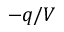Convert formula to latex. <formula><loc_0><loc_0><loc_500><loc_500>- q / V</formula> 